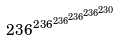<formula> <loc_0><loc_0><loc_500><loc_500>2 3 6 ^ { 2 3 6 ^ { 2 3 6 ^ { 2 3 6 ^ { 2 3 6 ^ { 2 3 0 } } } } }</formula> 